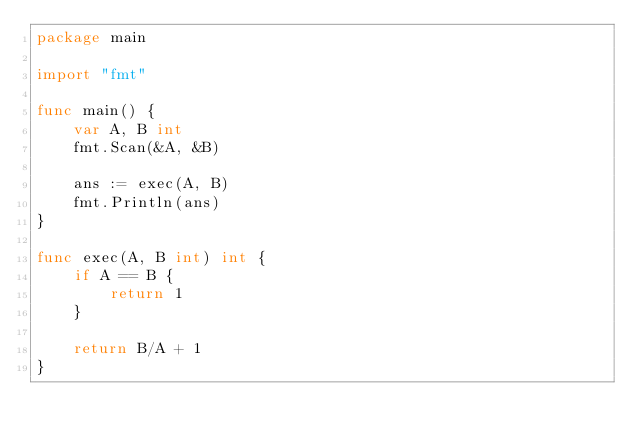Convert code to text. <code><loc_0><loc_0><loc_500><loc_500><_Go_>package main

import "fmt"

func main() {
	var A, B int
	fmt.Scan(&A, &B)

	ans := exec(A, B)
	fmt.Println(ans)
}

func exec(A, B int) int {
	if A == B {
		return 1
	}

	return B/A + 1
}
</code> 